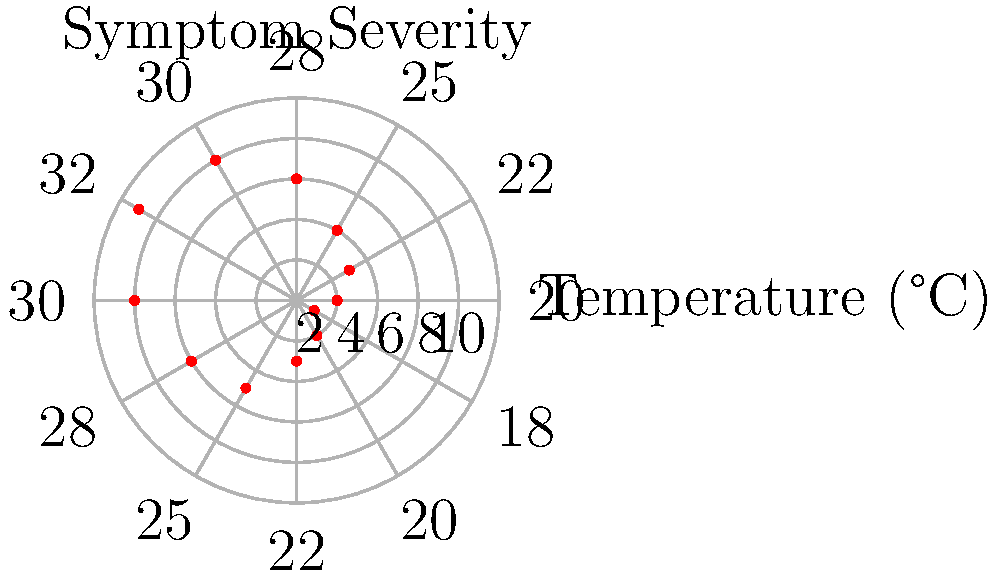Based on the polar plot showing the correlation between temperature fluctuations and symptom severity for a chronic illness, at which temperature (in °C) does the patient experience the highest symptom severity? To determine the temperature at which the patient experiences the highest symptom severity, we need to follow these steps:

1. Observe the polar plot, where:
   - The circular grid represents symptom severity (increasing from 0 to 10)
   - The angles represent different temperatures (labeled around the outer circle)
   - Red dots indicate the symptom severity at each temperature

2. Identify the red dot that is furthest from the center of the plot. This represents the highest symptom severity.

3. The furthest red dot appears to be at the 9 on the severity scale.

4. Trace this point to the corresponding temperature label on the outer circle.

5. The temperature associated with this highest severity point is 32°C.

Therefore, the patient experiences the highest symptom severity at a temperature of 32°C.
Answer: 32°C 